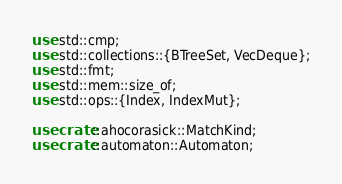<code> <loc_0><loc_0><loc_500><loc_500><_Rust_>use std::cmp;
use std::collections::{BTreeSet, VecDeque};
use std::fmt;
use std::mem::size_of;
use std::ops::{Index, IndexMut};

use crate::ahocorasick::MatchKind;
use crate::automaton::Automaton;</code> 